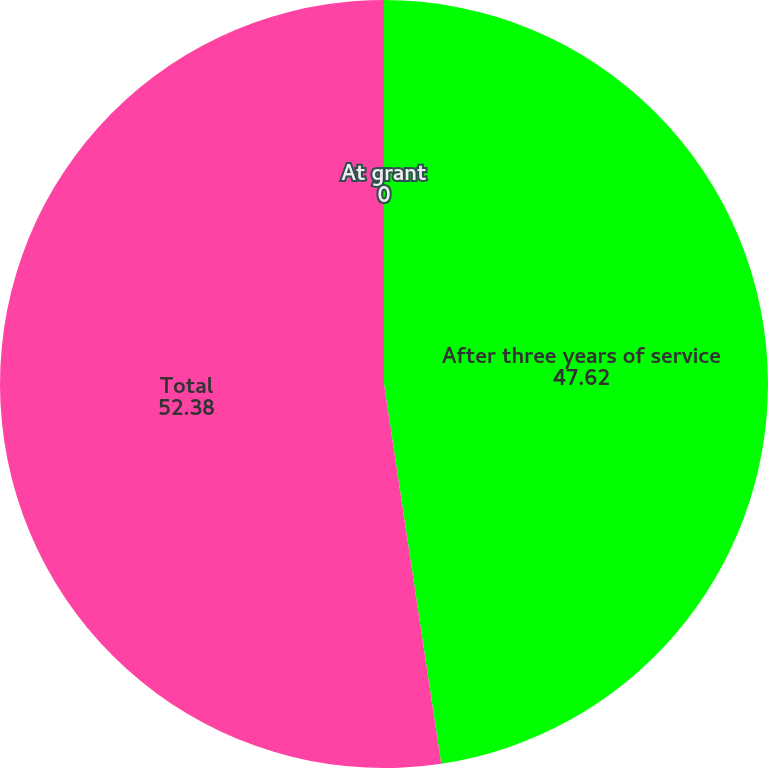Convert chart. <chart><loc_0><loc_0><loc_500><loc_500><pie_chart><fcel>At grant<fcel>After three years of service<fcel>Total<nl><fcel>0.0%<fcel>47.62%<fcel>52.38%<nl></chart> 